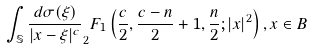Convert formula to latex. <formula><loc_0><loc_0><loc_500><loc_500>\int _ { \mathbb { S } } \frac { d \sigma ( \xi ) } { | x - \xi | ^ { c } } _ { 2 } F _ { 1 } \left ( \frac { c } { 2 } , \frac { c - n } { 2 } + 1 , \frac { n } { 2 } ; | x | ^ { 2 } \right ) , x \in B</formula> 